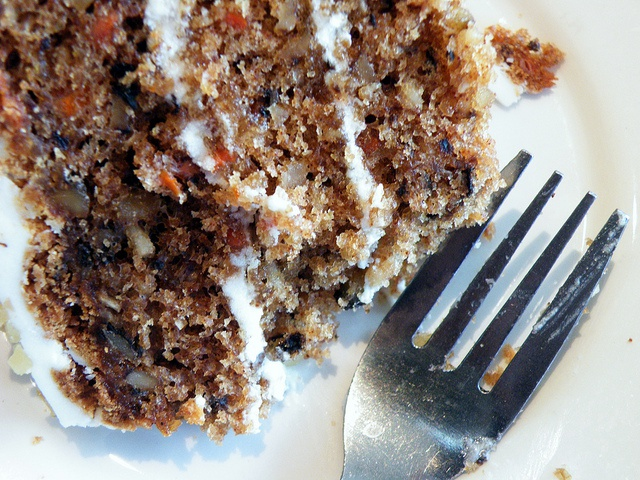Describe the objects in this image and their specific colors. I can see cake in brown, maroon, black, lightgray, and gray tones and fork in brown, black, gray, and darkgray tones in this image. 